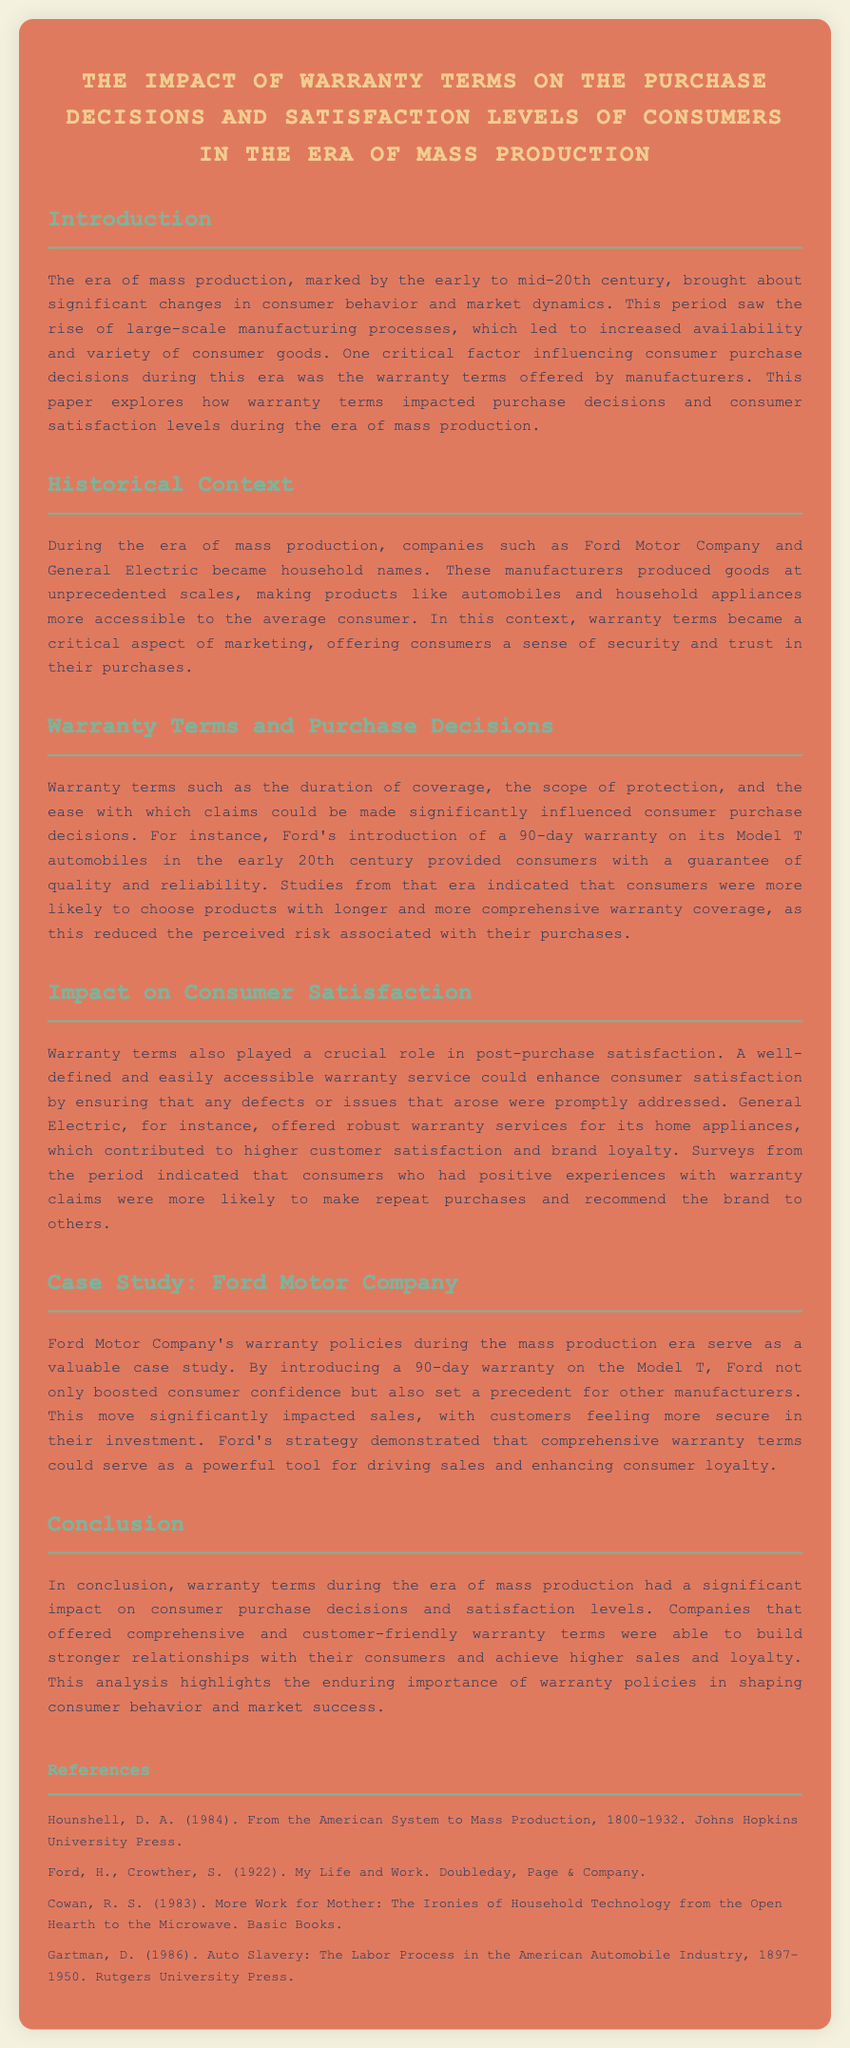What was the duration of Ford's warranty on the Model T? The document states that Ford offered a 90-day warranty on its Model T automobiles in the early 20th century.
Answer: 90-day Which company is mentioned as offering robust warranty services for its home appliances? General Electric is noted in the document for offering robust warranty services that contributed to higher customer satisfaction.
Answer: General Electric What significant era is the document focused on? The document emphasizes the era of mass production, marking significant changes in consumer behavior and market dynamics.
Answer: Mass production What impact did warranty terms have on consumer purchase decisions according to the document? The document indicates that longer and more comprehensive warranty coverage reduced perceived risk, thus influencing consumer purchase decisions positively.
Answer: Reduced perceived risk Which automotive company set a precedent for warranty terms in the document? Ford Motor Company is highlighted as having influenced warranty policies and consumer confidence through its warranty strategy.
Answer: Ford Motor Company 